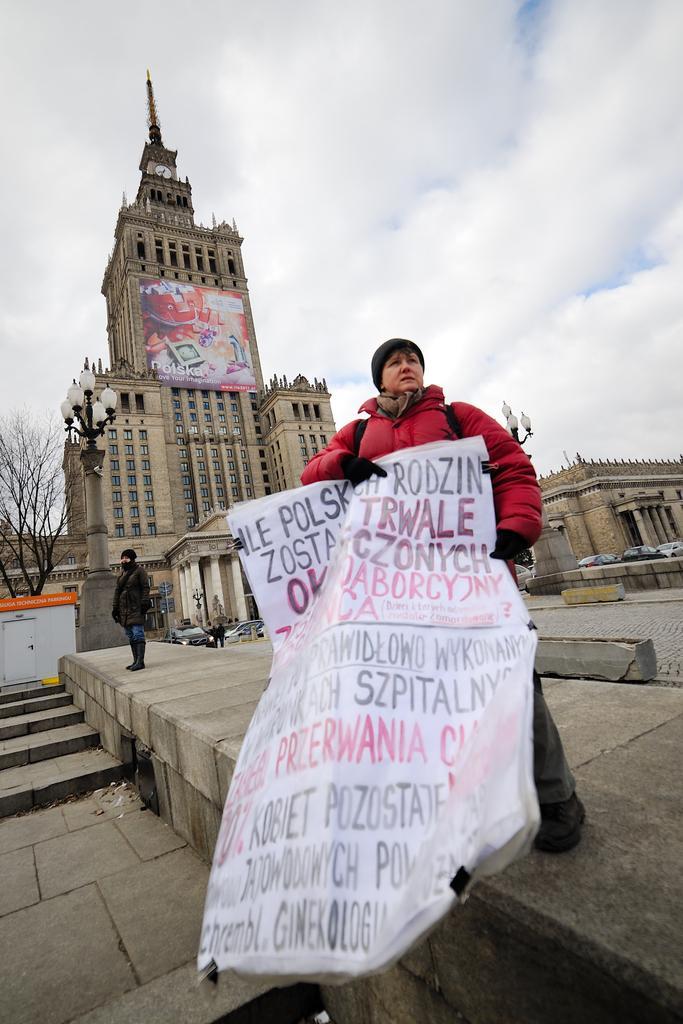Can you describe this image briefly? In the image there is a person standing on a surface and the person is holding a banner containing some text, in the background there is a huge building and there is a poster in front of that building, there are huge lights on the either side of the building and on the left side there is a tree. 